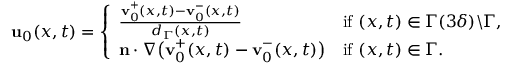Convert formula to latex. <formula><loc_0><loc_0><loc_500><loc_500>\begin{array} { r } { u _ { 0 } ( x , t ) = \left \{ \begin{array} { l l } { \frac { v _ { 0 } ^ { + } ( x , t ) - v _ { 0 } ^ { - } ( x , t ) } { d _ { \Gamma } ( x , t ) } } & { i f ( x , t ) \in \Gamma ( 3 \delta ) \ \Gamma , } \\ { n \cdot \nabla \left ( v _ { 0 } ^ { + } ( x , t ) - v _ { 0 } ^ { - } ( x , t ) \right ) } & { i f ( x , t ) \in \Gamma . } \end{array} } \end{array}</formula> 